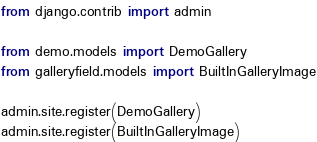Convert code to text. <code><loc_0><loc_0><loc_500><loc_500><_Python_>from django.contrib import admin

from demo.models import DemoGallery
from galleryfield.models import BuiltInGalleryImage

admin.site.register(DemoGallery)
admin.site.register(BuiltInGalleryImage)
</code> 